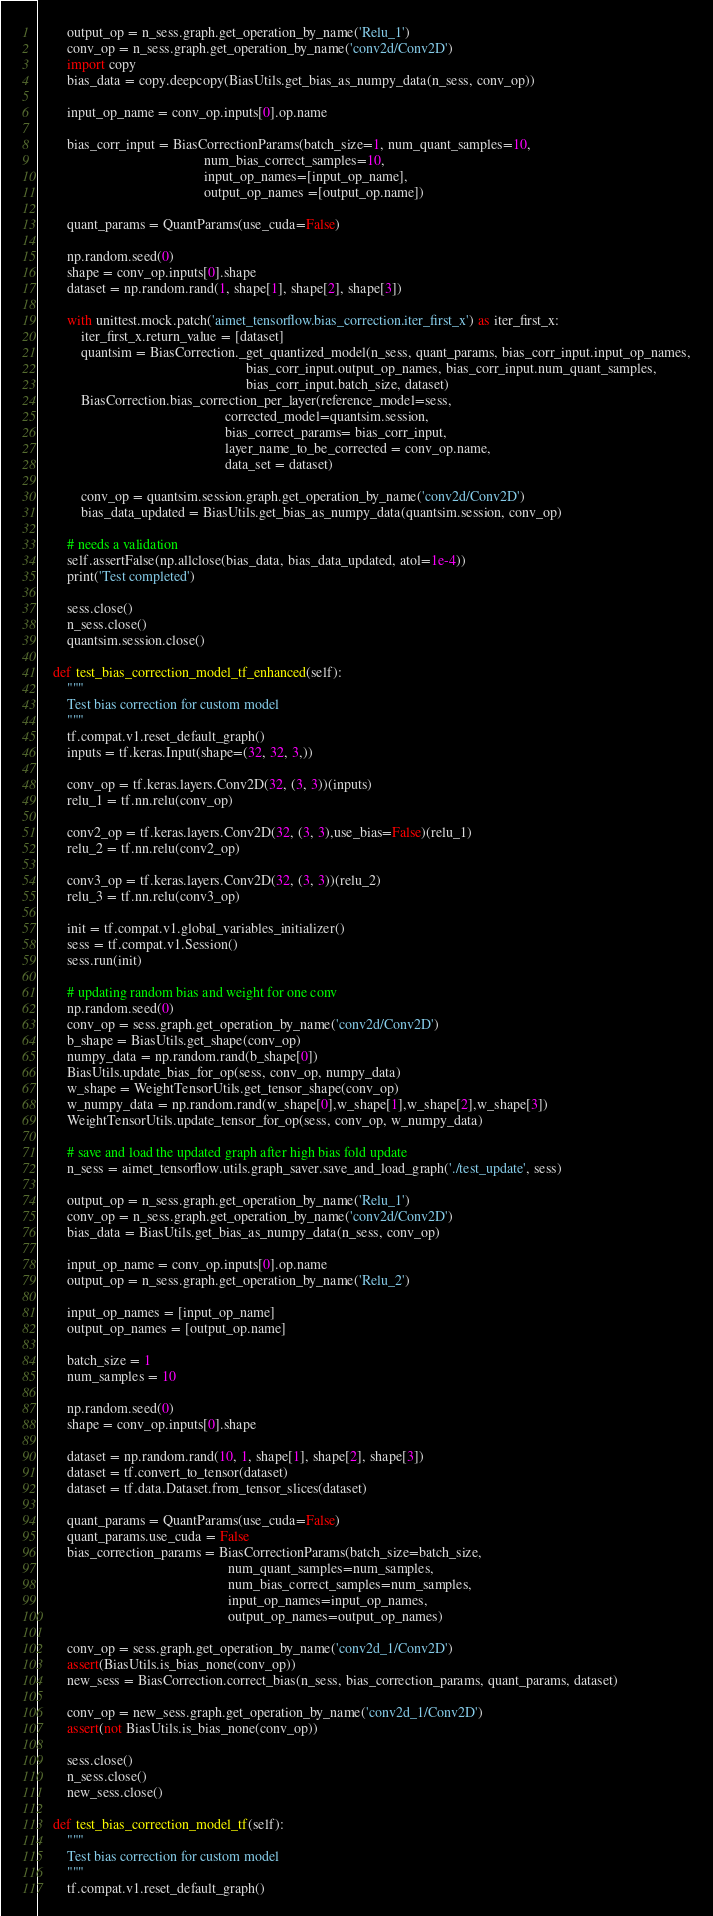<code> <loc_0><loc_0><loc_500><loc_500><_Python_>
        output_op = n_sess.graph.get_operation_by_name('Relu_1')
        conv_op = n_sess.graph.get_operation_by_name('conv2d/Conv2D')
        import copy
        bias_data = copy.deepcopy(BiasUtils.get_bias_as_numpy_data(n_sess, conv_op))

        input_op_name = conv_op.inputs[0].op.name

        bias_corr_input = BiasCorrectionParams(batch_size=1, num_quant_samples=10,
                                               num_bias_correct_samples=10,
                                               input_op_names=[input_op_name],
                                               output_op_names =[output_op.name])

        quant_params = QuantParams(use_cuda=False)

        np.random.seed(0)
        shape = conv_op.inputs[0].shape
        dataset = np.random.rand(1, shape[1], shape[2], shape[3])

        with unittest.mock.patch('aimet_tensorflow.bias_correction.iter_first_x') as iter_first_x:
            iter_first_x.return_value = [dataset]
            quantsim = BiasCorrection._get_quantized_model(n_sess, quant_params, bias_corr_input.input_op_names,
                                                           bias_corr_input.output_op_names, bias_corr_input.num_quant_samples,
                                                           bias_corr_input.batch_size, dataset)
            BiasCorrection.bias_correction_per_layer(reference_model=sess,
                                                     corrected_model=quantsim.session,
                                                     bias_correct_params= bias_corr_input,
                                                     layer_name_to_be_corrected = conv_op.name,
                                                     data_set = dataset)

            conv_op = quantsim.session.graph.get_operation_by_name('conv2d/Conv2D')
            bias_data_updated = BiasUtils.get_bias_as_numpy_data(quantsim.session, conv_op)

        # needs a validation
        self.assertFalse(np.allclose(bias_data, bias_data_updated, atol=1e-4))
        print('Test completed')

        sess.close()
        n_sess.close()
        quantsim.session.close()

    def test_bias_correction_model_tf_enhanced(self):
        """
        Test bias correction for custom model
        """
        tf.compat.v1.reset_default_graph()
        inputs = tf.keras.Input(shape=(32, 32, 3,))

        conv_op = tf.keras.layers.Conv2D(32, (3, 3))(inputs)
        relu_1 = tf.nn.relu(conv_op)

        conv2_op = tf.keras.layers.Conv2D(32, (3, 3),use_bias=False)(relu_1)
        relu_2 = tf.nn.relu(conv2_op)

        conv3_op = tf.keras.layers.Conv2D(32, (3, 3))(relu_2)
        relu_3 = tf.nn.relu(conv3_op)

        init = tf.compat.v1.global_variables_initializer()
        sess = tf.compat.v1.Session()
        sess.run(init)

        # updating random bias and weight for one conv
        np.random.seed(0)
        conv_op = sess.graph.get_operation_by_name('conv2d/Conv2D')
        b_shape = BiasUtils.get_shape(conv_op)
        numpy_data = np.random.rand(b_shape[0])
        BiasUtils.update_bias_for_op(sess, conv_op, numpy_data)
        w_shape = WeightTensorUtils.get_tensor_shape(conv_op)
        w_numpy_data = np.random.rand(w_shape[0],w_shape[1],w_shape[2],w_shape[3])
        WeightTensorUtils.update_tensor_for_op(sess, conv_op, w_numpy_data)

        # save and load the updated graph after high bias fold update
        n_sess = aimet_tensorflow.utils.graph_saver.save_and_load_graph('./test_update', sess)

        output_op = n_sess.graph.get_operation_by_name('Relu_1')
        conv_op = n_sess.graph.get_operation_by_name('conv2d/Conv2D')
        bias_data = BiasUtils.get_bias_as_numpy_data(n_sess, conv_op)

        input_op_name = conv_op.inputs[0].op.name
        output_op = n_sess.graph.get_operation_by_name('Relu_2')

        input_op_names = [input_op_name]
        output_op_names = [output_op.name]

        batch_size = 1
        num_samples = 10

        np.random.seed(0)
        shape = conv_op.inputs[0].shape

        dataset = np.random.rand(10, 1, shape[1], shape[2], shape[3])
        dataset = tf.convert_to_tensor(dataset)
        dataset = tf.data.Dataset.from_tensor_slices(dataset)

        quant_params = QuantParams(use_cuda=False)
        quant_params.use_cuda = False
        bias_correction_params = BiasCorrectionParams(batch_size=batch_size,
                                                      num_quant_samples=num_samples,
                                                      num_bias_correct_samples=num_samples,
                                                      input_op_names=input_op_names,
                                                      output_op_names=output_op_names)

        conv_op = sess.graph.get_operation_by_name('conv2d_1/Conv2D')
        assert(BiasUtils.is_bias_none(conv_op))
        new_sess = BiasCorrection.correct_bias(n_sess, bias_correction_params, quant_params, dataset)

        conv_op = new_sess.graph.get_operation_by_name('conv2d_1/Conv2D')
        assert(not BiasUtils.is_bias_none(conv_op))

        sess.close()
        n_sess.close()
        new_sess.close()

    def test_bias_correction_model_tf(self):
        """
        Test bias correction for custom model
        """
        tf.compat.v1.reset_default_graph()</code> 